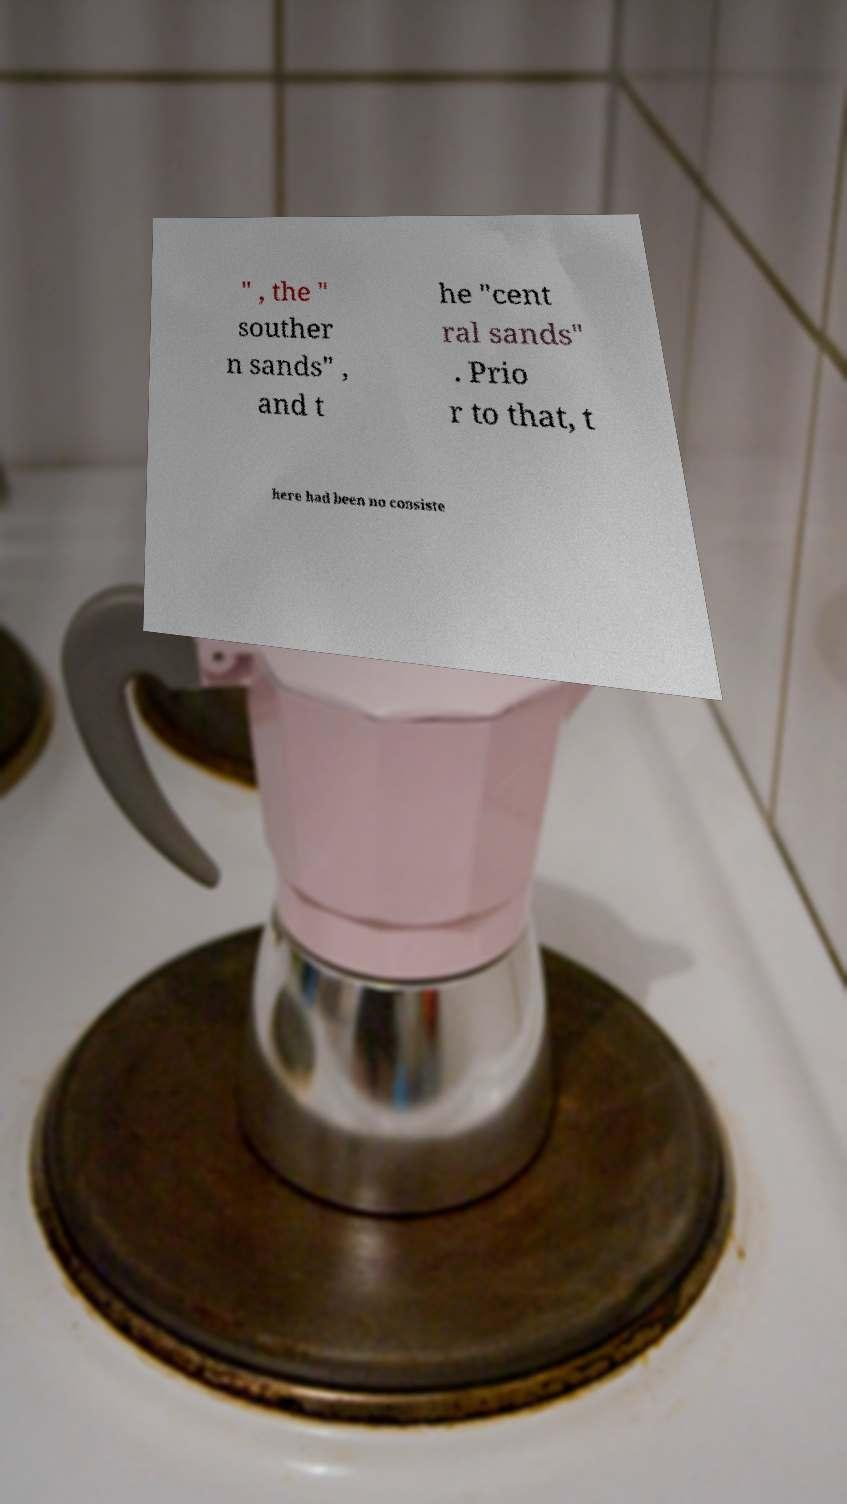What messages or text are displayed in this image? I need them in a readable, typed format. " , the " souther n sands" , and t he "cent ral sands" . Prio r to that, t here had been no consiste 